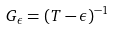<formula> <loc_0><loc_0><loc_500><loc_500>G _ { \epsilon } = ( T - \epsilon ) ^ { - 1 }</formula> 